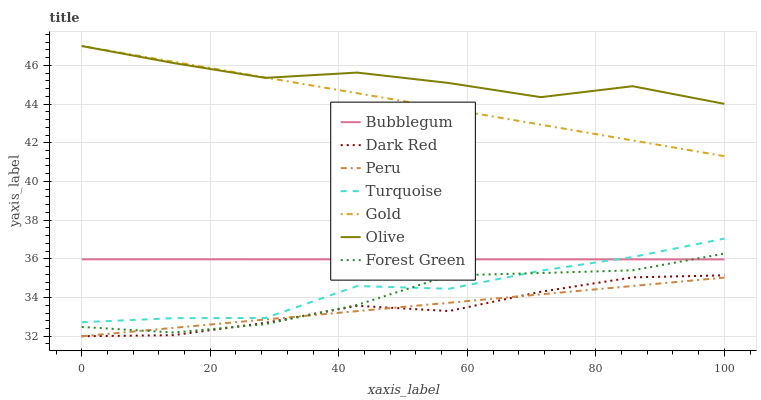Does Gold have the minimum area under the curve?
Answer yes or no. No. Does Gold have the maximum area under the curve?
Answer yes or no. No. Is Gold the smoothest?
Answer yes or no. No. Is Gold the roughest?
Answer yes or no. No. Does Gold have the lowest value?
Answer yes or no. No. Does Dark Red have the highest value?
Answer yes or no. No. Is Peru less than Gold?
Answer yes or no. Yes. Is Bubblegum greater than Peru?
Answer yes or no. Yes. Does Peru intersect Gold?
Answer yes or no. No. 